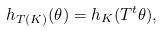Convert formula to latex. <formula><loc_0><loc_0><loc_500><loc_500>h _ { T ( K ) } ( \theta ) = h _ { K } ( T ^ { t } \theta ) ,</formula> 